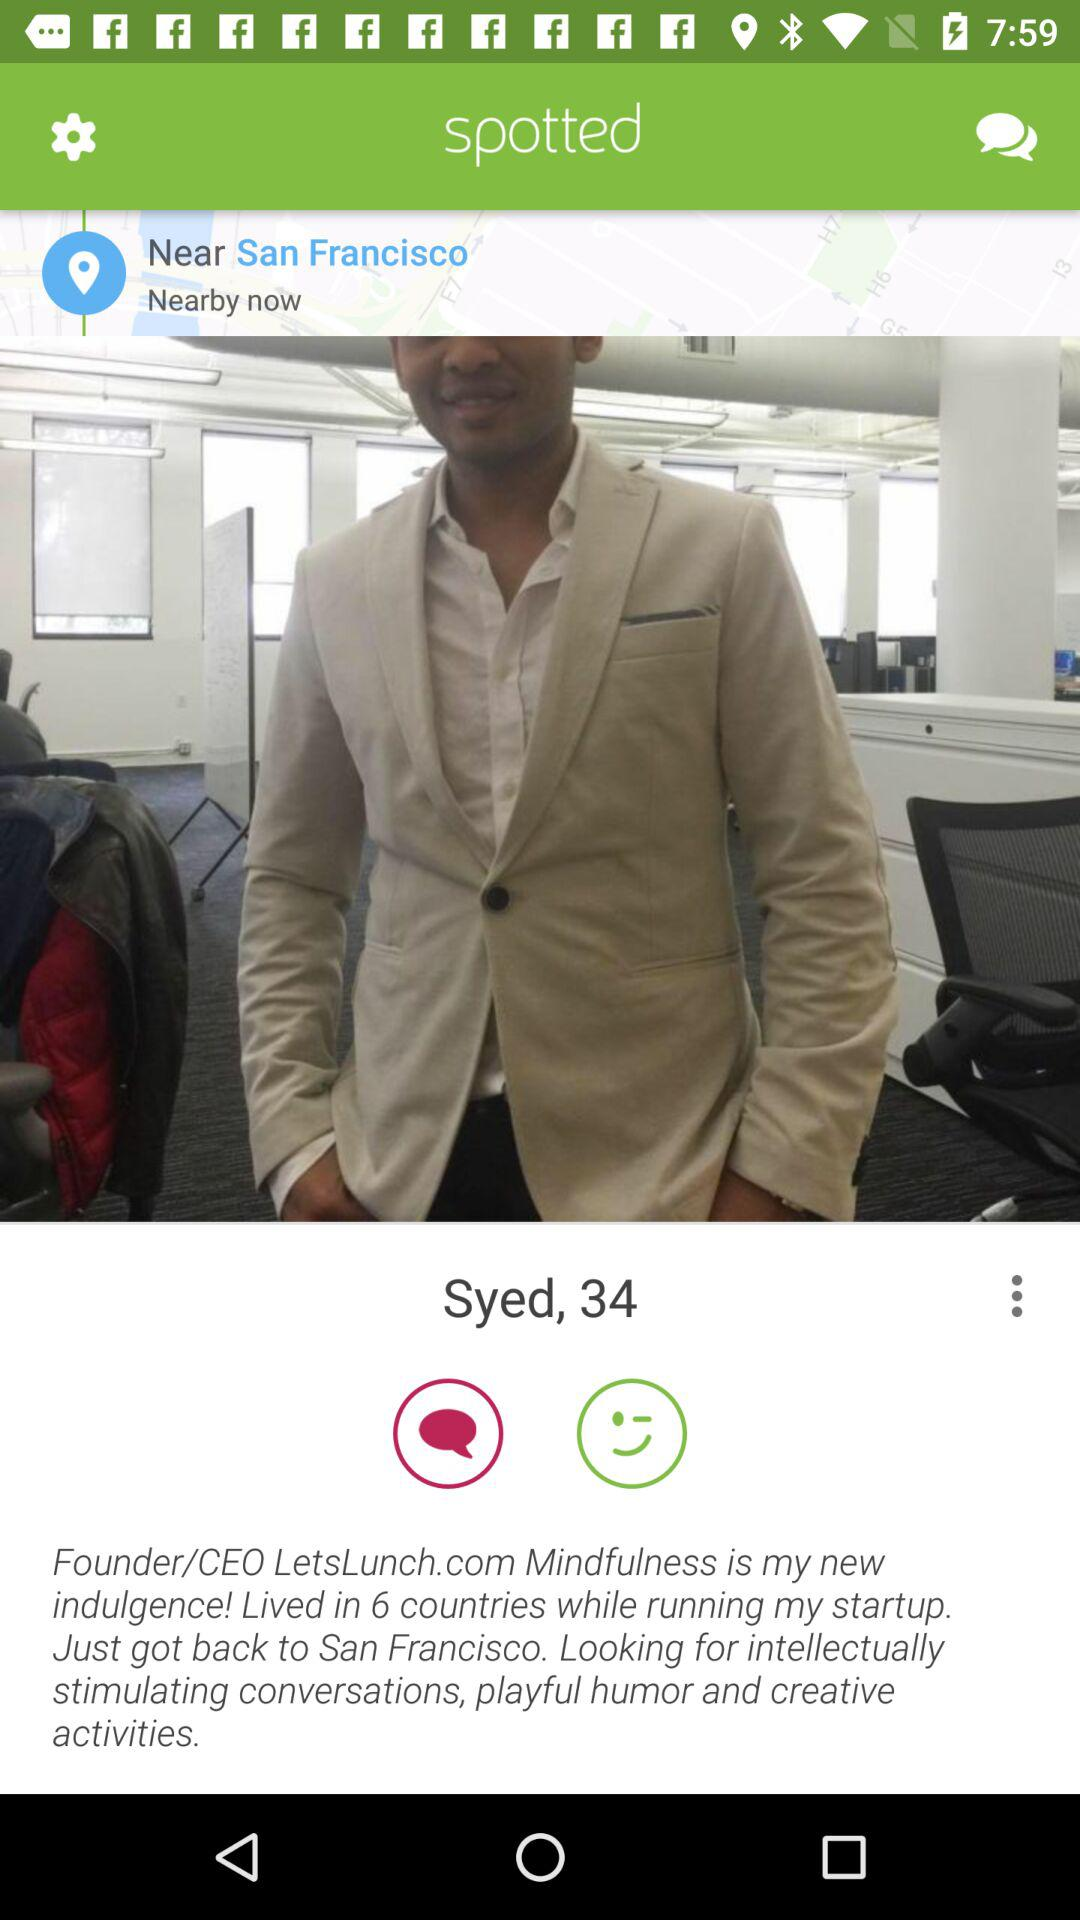What is the age of Syed? Syed is 34 years old. 